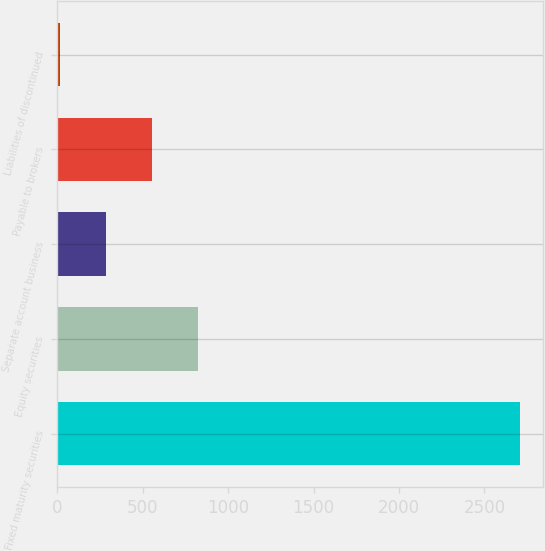Convert chart to OTSL. <chart><loc_0><loc_0><loc_500><loc_500><bar_chart><fcel>Fixed maturity securities<fcel>Equity securities<fcel>Separate account business<fcel>Payable to brokers<fcel>Liabilities of discontinued<nl><fcel>2710<fcel>823.5<fcel>284.5<fcel>554<fcel>15<nl></chart> 